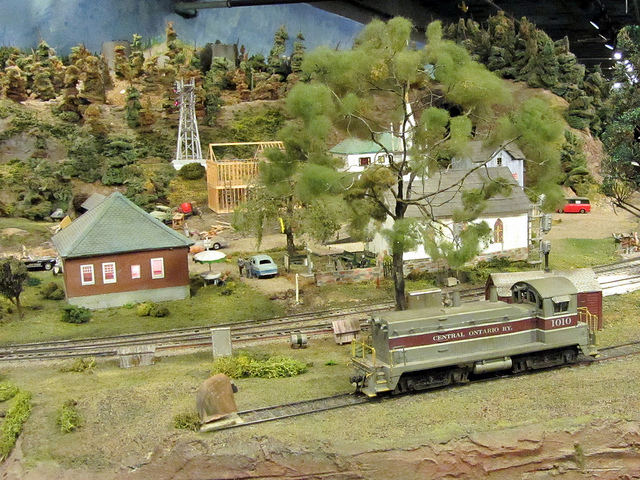Please identify all text content in this image. CENTRAL 1010 